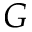Convert formula to latex. <formula><loc_0><loc_0><loc_500><loc_500>G</formula> 